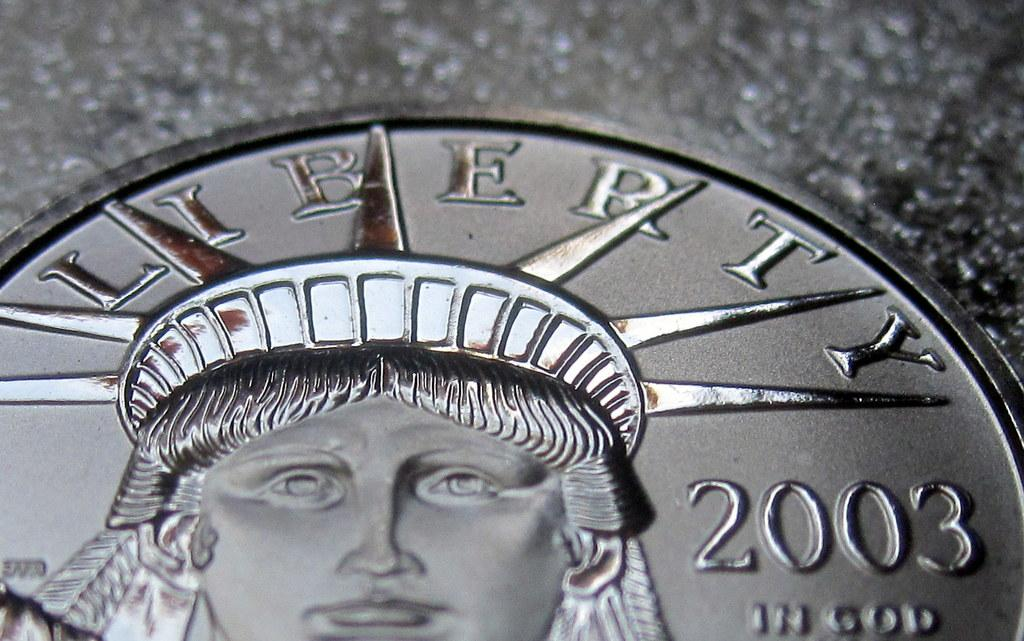What object is the main focus of the image? There is a coin in the image. Where is the coin located? The coin is on a surface. What type of seed is being discussed in the image? There is no discussion or seed present in the image; it only features a coin on a surface. 